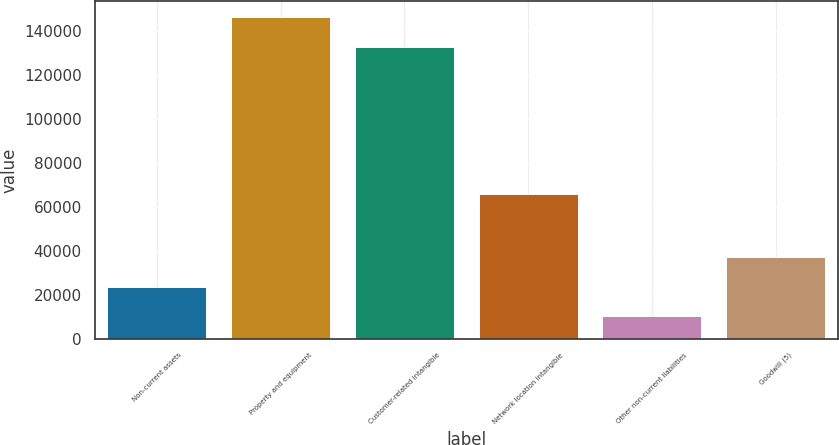Convert chart. <chart><loc_0><loc_0><loc_500><loc_500><bar_chart><fcel>Non-current assets<fcel>Property and equipment<fcel>Customer-related intangible<fcel>Network location intangible<fcel>Other non-current liabilities<fcel>Goodwill (5)<nl><fcel>23798.2<fcel>146217<fcel>132897<fcel>66069<fcel>10478<fcel>37118.4<nl></chart> 